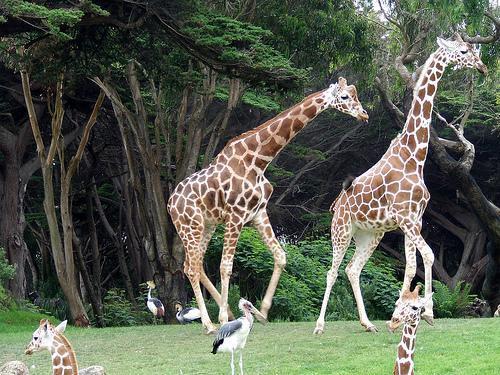How many giraffe are there?
Give a very brief answer. 4. 